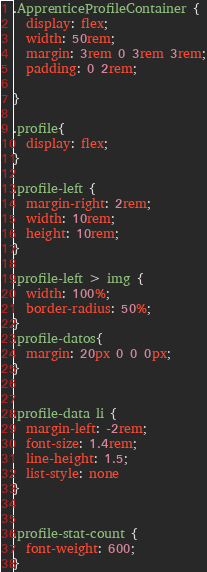Convert code to text. <code><loc_0><loc_0><loc_500><loc_500><_CSS_>
.ApprenticeProfileContainer {
  display: flex;
  width: 50rem;
  margin: 3rem 0 3rem 3rem;
  padding: 0 2rem;
  
}

.profile{
  display: flex;
}

.profile-left {
  margin-right: 2rem;
  width: 10rem;
  height: 10rem;
}

.profile-left > img {
  width: 100%;
  border-radius: 50%;
}
.profile-datos{
  margin: 20px 0 0 0px;
}


.profile-data li {
  margin-left: -2rem;
  font-size: 1.4rem;
  line-height: 1.5;
  list-style: none
}


.profile-stat-count {
  font-weight: 600;
}
</code> 